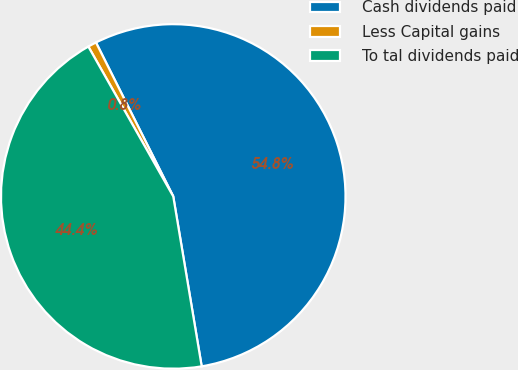<chart> <loc_0><loc_0><loc_500><loc_500><pie_chart><fcel>Cash dividends paid<fcel>Less Capital gains<fcel>To tal dividends paid<nl><fcel>54.77%<fcel>0.8%<fcel>44.44%<nl></chart> 